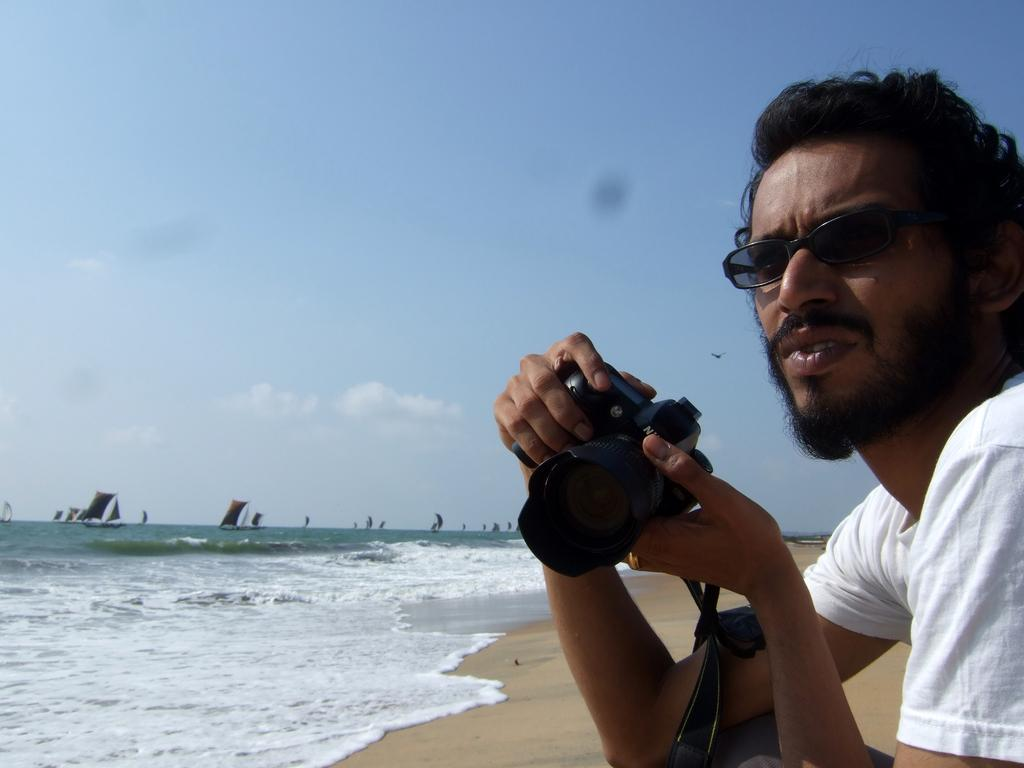What is the main subject of the image? The main subject of the image is a man. Can you describe the man's appearance? The man is wearing clothes and spectacles. What is the man holding in his hand? The man is holding a video camera in his hand. What type of environment is visible in the image? There is sand and water visible in the image, along with boats. What is the color of the sky in the image? The sky is pale blue in the image. What condition is the receipt in, and who is holding it in the image? There is no receipt present in the image. How many girls can be seen in the image? There are no girls present in the image. 